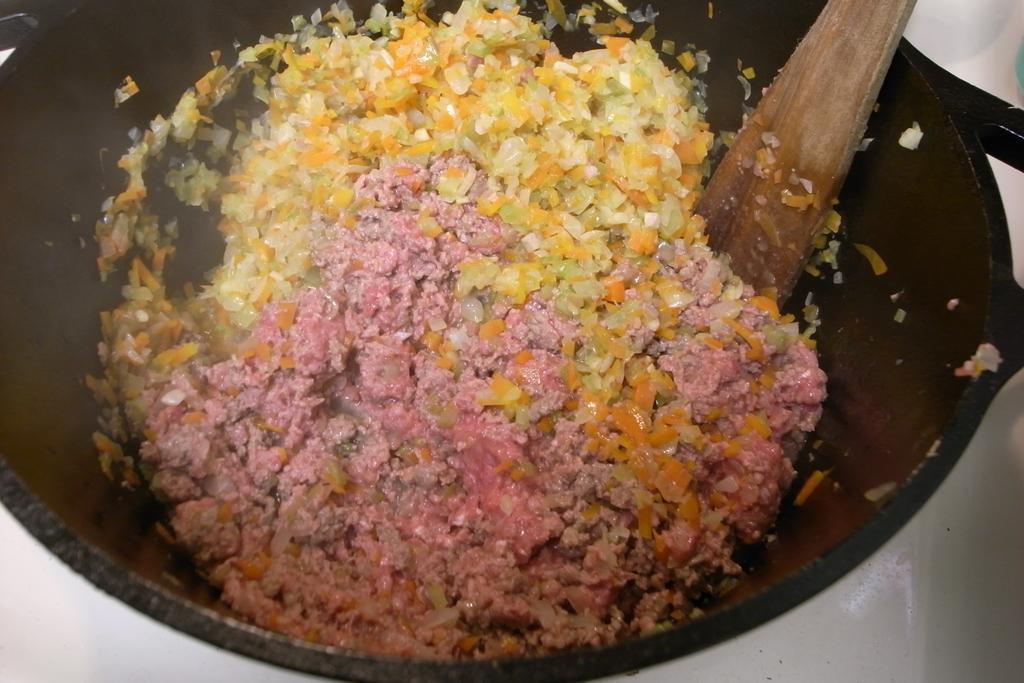Please provide a concise description of this image. In this image we can see a bowl with some food and a spoon. 